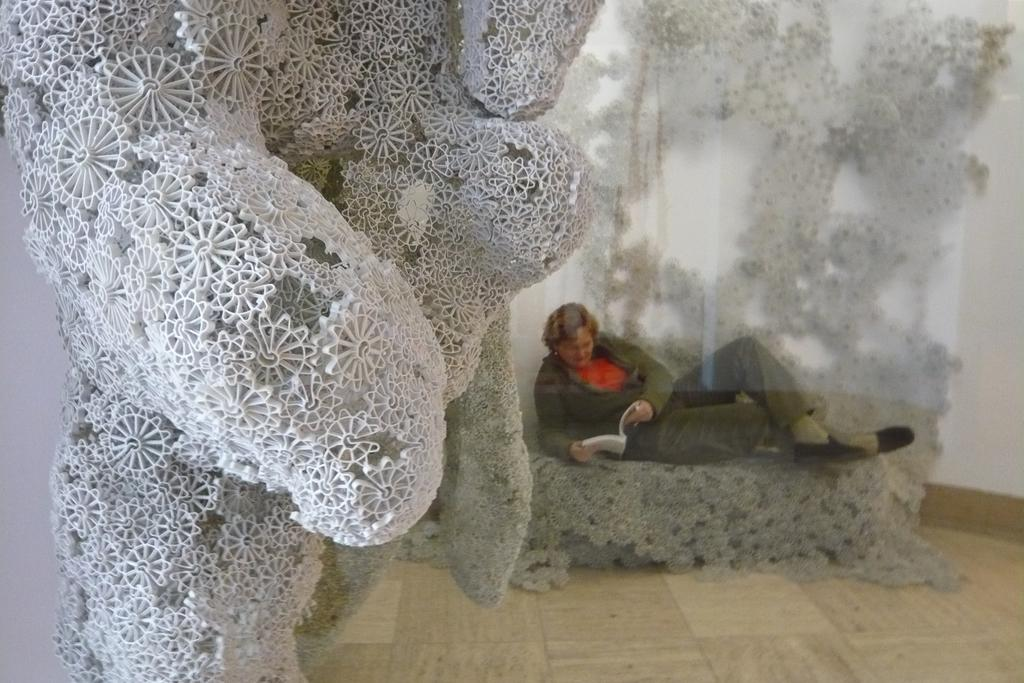What is the main subject in the image? There is a sculpture in the image. What is the man behind the sculpture doing? The man is sitting behind the sculpture and holding a book. What is visible behind the man? There is a wall behind the man. What type of brake is being used by the man in the image? There is no brake present in the image; the man is sitting behind a sculpture and holding a book. How does the man pump the oatmeal in the image? There is no oatmeal or pump present in the image. 